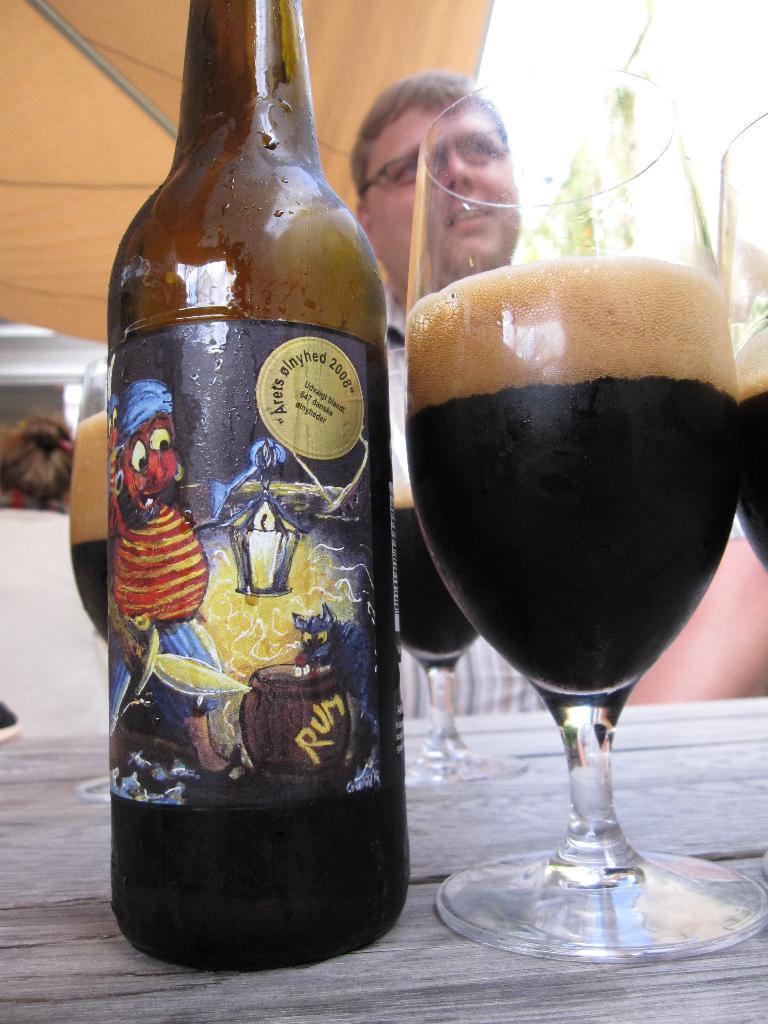How would you summarize this image in a sentence or two? There is a wine bottle and a glass with a drink, placed on the table. In the background there is a man sitting in front of the table, wearing spectacles. 